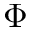Convert formula to latex. <formula><loc_0><loc_0><loc_500><loc_500>\Phi</formula> 